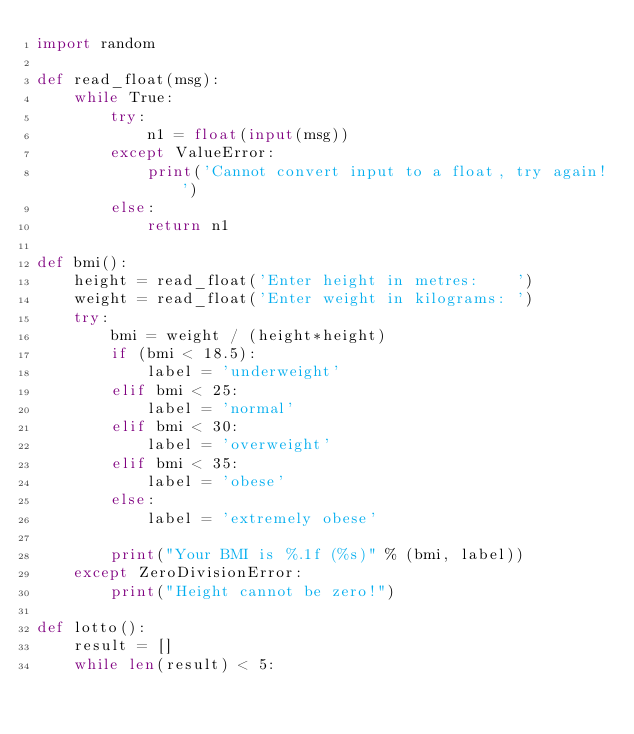<code> <loc_0><loc_0><loc_500><loc_500><_Python_>import random

def read_float(msg):
    while True:
        try:
            n1 = float(input(msg))
        except ValueError:
            print('Cannot convert input to a float, try again!')
        else:
            return n1

def bmi():
    height = read_float('Enter height in metres:    ')
    weight = read_float('Enter weight in kilograms: ')
    try:
        bmi = weight / (height*height)
        if (bmi < 18.5):
            label = 'underweight'
        elif bmi < 25:
            label = 'normal'
        elif bmi < 30:
            label = 'overweight'
        elif bmi < 35:
            label = 'obese'
        else:
            label = 'extremely obese'

        print("Your BMI is %.1f (%s)" % (bmi, label))
    except ZeroDivisionError:
        print("Height cannot be zero!")

def lotto():
    result = []
    while len(result) < 5:</code> 